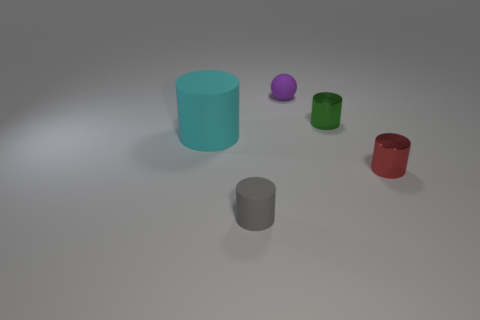Subtract all large cyan matte cylinders. How many cylinders are left? 3 Add 4 small spheres. How many objects exist? 9 Subtract all cylinders. How many objects are left? 1 Subtract all yellow balls. How many yellow cylinders are left? 0 Subtract all green metallic objects. Subtract all small objects. How many objects are left? 0 Add 4 purple rubber balls. How many purple rubber balls are left? 5 Add 5 matte balls. How many matte balls exist? 6 Subtract all cyan cylinders. How many cylinders are left? 3 Subtract 1 red cylinders. How many objects are left? 4 Subtract 1 cylinders. How many cylinders are left? 3 